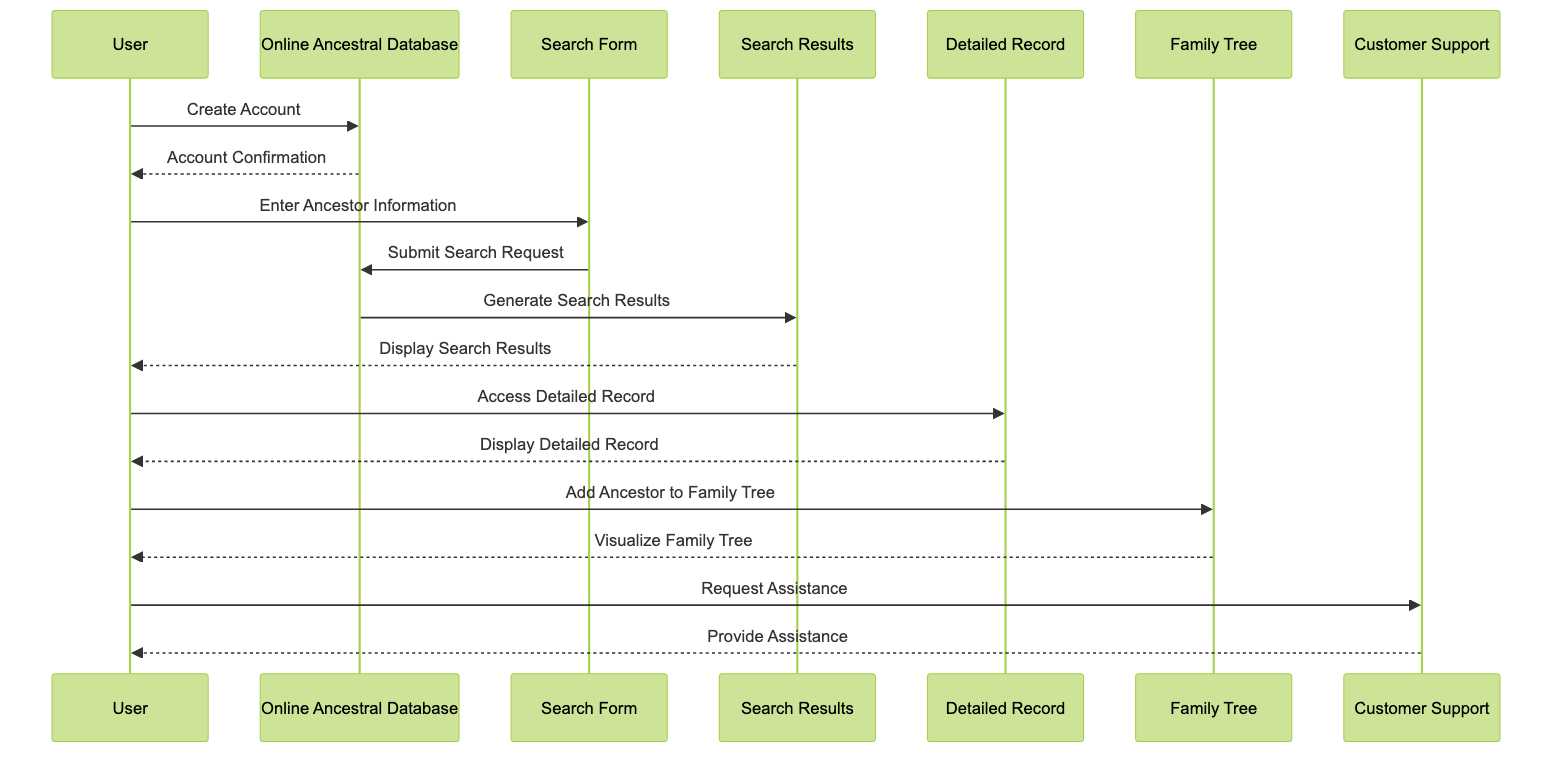What is the first action the User takes? The diagram shows that the first action taken by the User is to create an account with the Online Ancestral Database. This is represented by the first arrow from User to Online Ancestral Database labeled "Create Account."
Answer: Create Account How many actors are represented in the diagram? There are a total of three actors represented in the diagram: User, Online Ancestral Database, and Customer Support. This can be confirmed by counting the unique participants listed at the beginning of the diagram.
Answer: 3 What does the User do after receiving Account Confirmation? After the User receives Account Confirmation from the Online Ancestral Database, the next action taken is to enter ancestor information into the Search Form, as shown by the following interaction in the diagram.
Answer: Enter Ancestor Information What is the last action indicated by the User in the sequence? The last action shown by the User in the sequence is to request assistance from Customer Support. This is represented in the diagram by the arrow leading from User to Customer Support labeled "Request Assistance."
Answer: Request Assistance What is displayed after the User accesses the Detailed Record? The Detailed Record displays detailed information about the ancestor after the User accesses it, as indicated by the arrow from Detailed Record to User labeled "Display Detailed Record."
Answer: Display Detailed Record How many messages does the User send during the sequence? The User sends a total of four messages during the sequence. They are: "Create Account," "Enter Ancestor Information," "Access Detailed Record," and "Request Assistance." They can be tracked by counting the arrows originating from the User in the diagram.
Answer: 4 Which object does the User interact with to create a visual representation of ancestral data? The User interacts with the Family Tree object to create a visual representation of ancestral data, as seen in the arrow going from User to Family Tree labeled "Add Ancestor to Family Tree."
Answer: Family Tree Why would a User contact Customer Support? A User may contact Customer Support for assistance with using the database or understanding records. This is confirmed by the arrow between User and Customer Support labeled "Request Assistance," which indicates a need for help.
Answer: For assistance How does the User view the updated Family Tree? The User views the updated Family Tree through the interaction labeled "Visualize Family Tree," where the Family Tree object sends a message back to the User. This indicates that upon adding an ancestor, the User can visualize the changes made.
Answer: Visualize Family Tree 